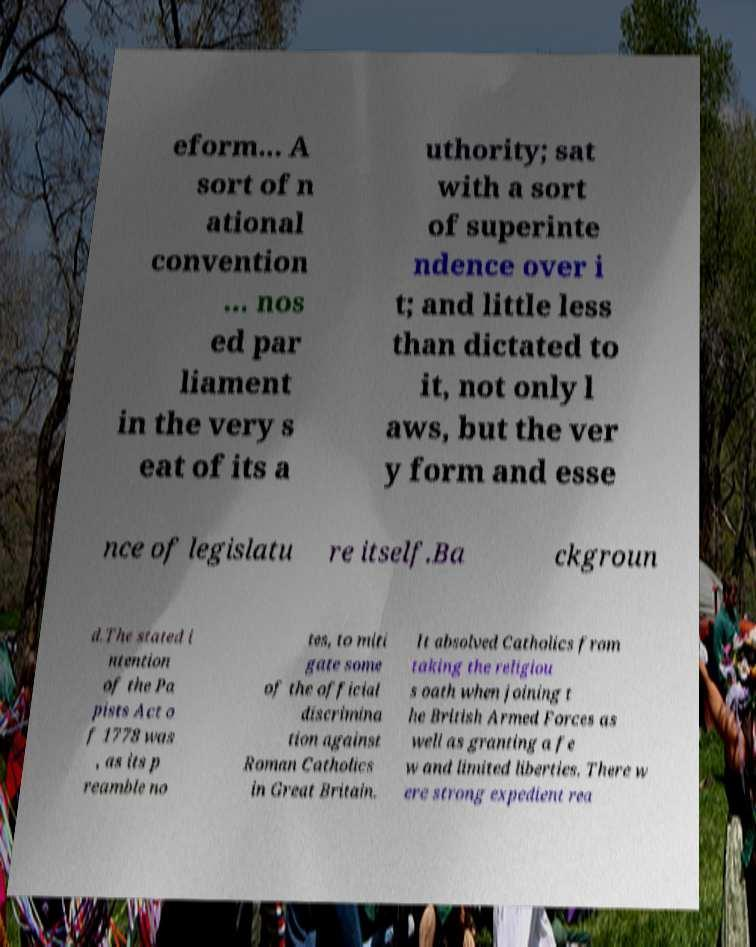I need the written content from this picture converted into text. Can you do that? eform... A sort of n ational convention ... nos ed par liament in the very s eat of its a uthority; sat with a sort of superinte ndence over i t; and little less than dictated to it, not only l aws, but the ver y form and esse nce of legislatu re itself.Ba ckgroun d.The stated i ntention of the Pa pists Act o f 1778 was , as its p reamble no tes, to miti gate some of the official discrimina tion against Roman Catholics in Great Britain. It absolved Catholics from taking the religiou s oath when joining t he British Armed Forces as well as granting a fe w and limited liberties. There w ere strong expedient rea 